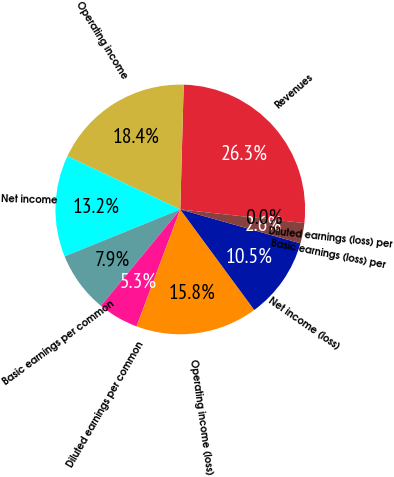Convert chart. <chart><loc_0><loc_0><loc_500><loc_500><pie_chart><fcel>Revenues<fcel>Operating income<fcel>Net income<fcel>Basic earnings per common<fcel>Diluted earnings per common<fcel>Operating income (loss)<fcel>Net income (loss)<fcel>Basic earnings (loss) per<fcel>Diluted earnings (loss) per<nl><fcel>26.31%<fcel>18.42%<fcel>13.16%<fcel>7.9%<fcel>5.27%<fcel>15.79%<fcel>10.53%<fcel>2.63%<fcel>0.0%<nl></chart> 